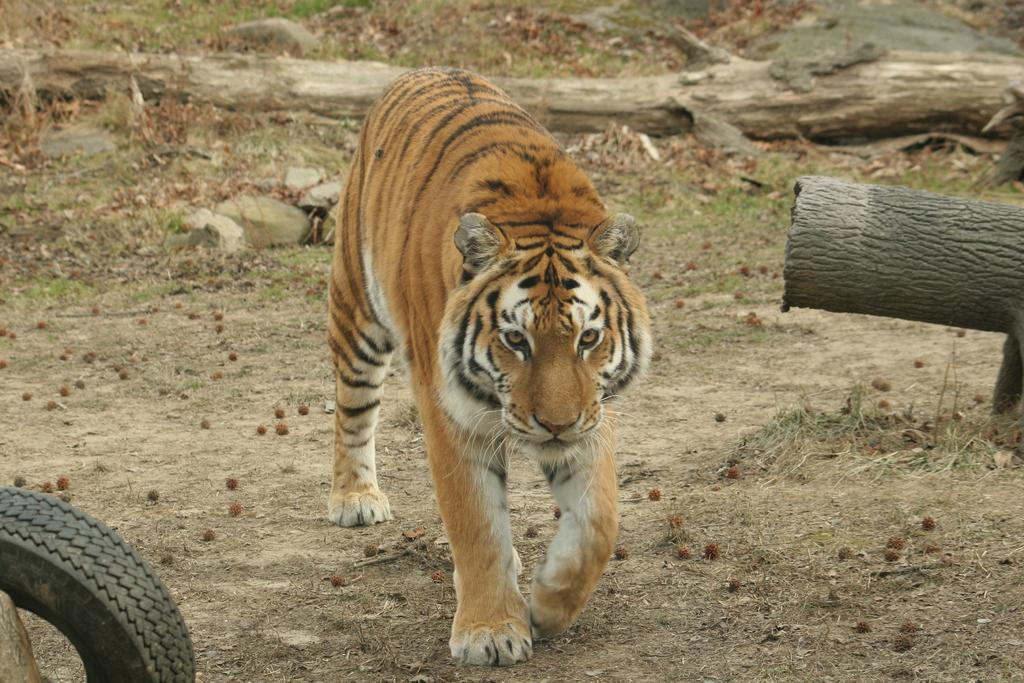What is the main subject of the image? There is a lion at the center of the image. What objects can be seen besides the lion? There are wooden sticks and a tyre in the image. Where is the tyre located in the image? The tyre is on the bottom left side of the image. What type of wine is being served in the box in the image? There is no wine or box present in the image; it features a lion, wooden sticks, and a tyre. 